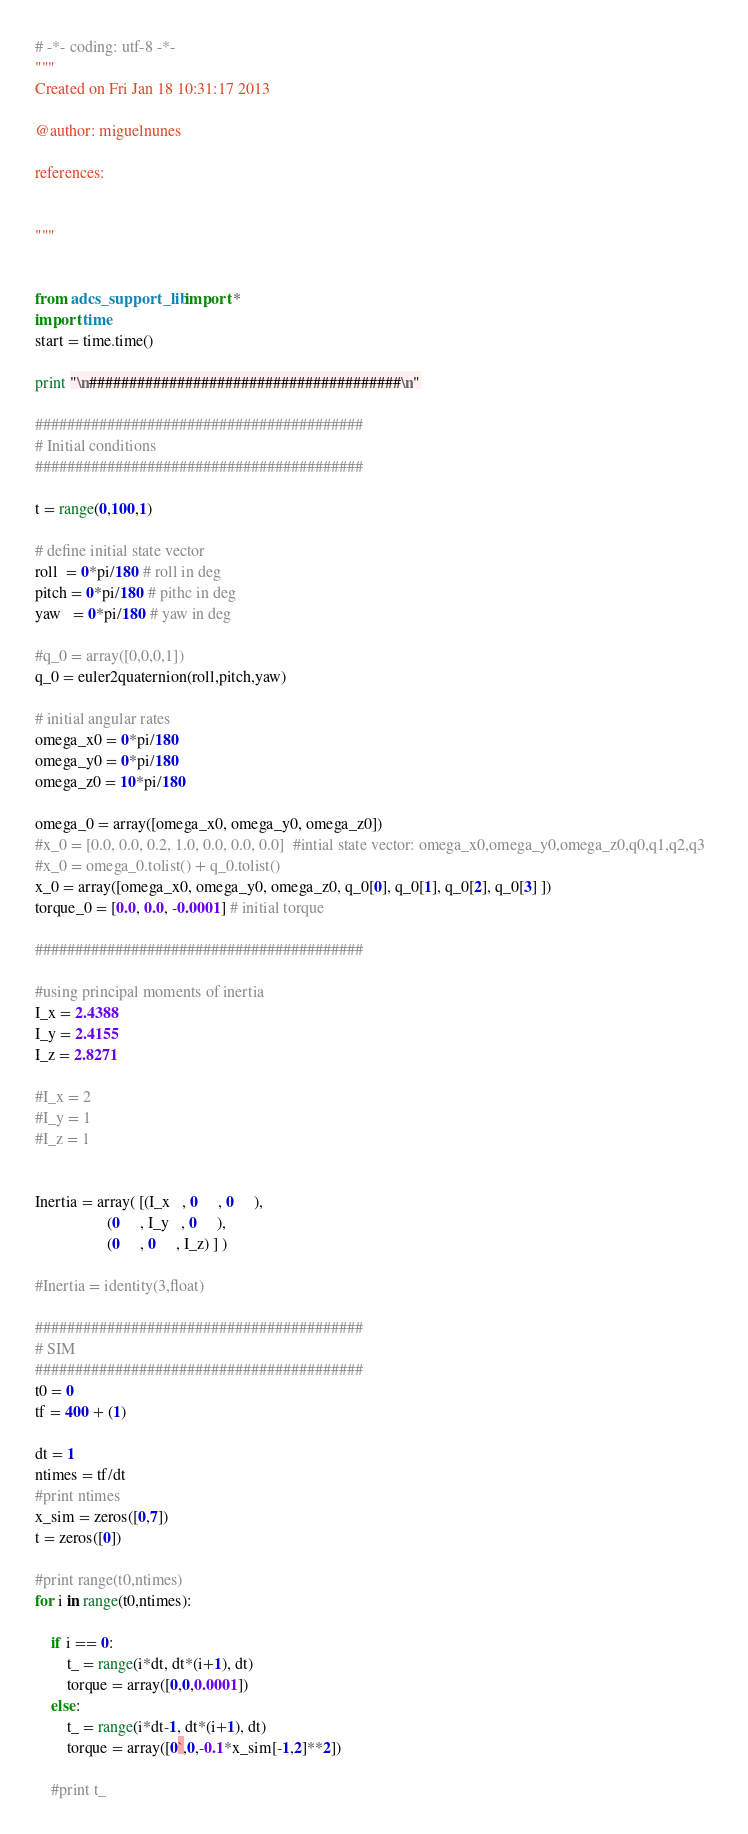<code> <loc_0><loc_0><loc_500><loc_500><_Python_># -*- coding: utf-8 -*-
"""
Created on Fri Jan 18 10:31:17 2013

@author: miguelnunes

references: 
    

"""


from adcs_support_lib import *
import time
start = time.time()

print "\n#######################################\n"

#########################################
# Initial conditions
#########################################

t = range(0,100,1)

# define initial state vector
roll  = 0*pi/180 # roll in deg
pitch = 0*pi/180 # pithc in deg
yaw   = 0*pi/180 # yaw in deg

#q_0 = array([0,0,0,1])
q_0 = euler2quaternion(roll,pitch,yaw)

# initial angular rates
omega_x0 = 0*pi/180
omega_y0 = 0*pi/180
omega_z0 = 10*pi/180

omega_0 = array([omega_x0, omega_y0, omega_z0])
#x_0 = [0.0, 0.0, 0.2, 1.0, 0.0, 0.0, 0.0]  #intial state vector: omega_x0,omega_y0,omega_z0,q0,q1,q2,q3  
#x_0 = omega_0.tolist() + q_0.tolist()
x_0 = array([omega_x0, omega_y0, omega_z0, q_0[0], q_0[1], q_0[2], q_0[3] ])
torque_0 = [0.0, 0.0, -0.0001] # initial torque

#########################################

#using principal moments of inertia
I_x = 2.4388
I_y = 2.4155
I_z = 2.8271

#I_x = 2
#I_y = 1
#I_z = 1


Inertia = array( [(I_x   , 0     , 0     ), 
                  (0     , I_y   , 0     ), 
                  (0     , 0     , I_z) ] )

#Inertia = identity(3,float)

#########################################
# SIM
#########################################
t0 = 0
tf = 400 + (1)

dt = 1
ntimes = tf/dt
#print ntimes
x_sim = zeros([0,7])
t = zeros([0])

#print range(t0,ntimes)
for i in range(t0,ntimes):

    if i == 0:
        t_ = range(i*dt, dt*(i+1), dt)
        torque = array([0,0,0.0001])
    else:       
        t_ = range(i*dt-1, dt*(i+1), dt)
        torque = array([0`,0,-0.1*x_sim[-1,2]**2])
        
    #print t_</code> 